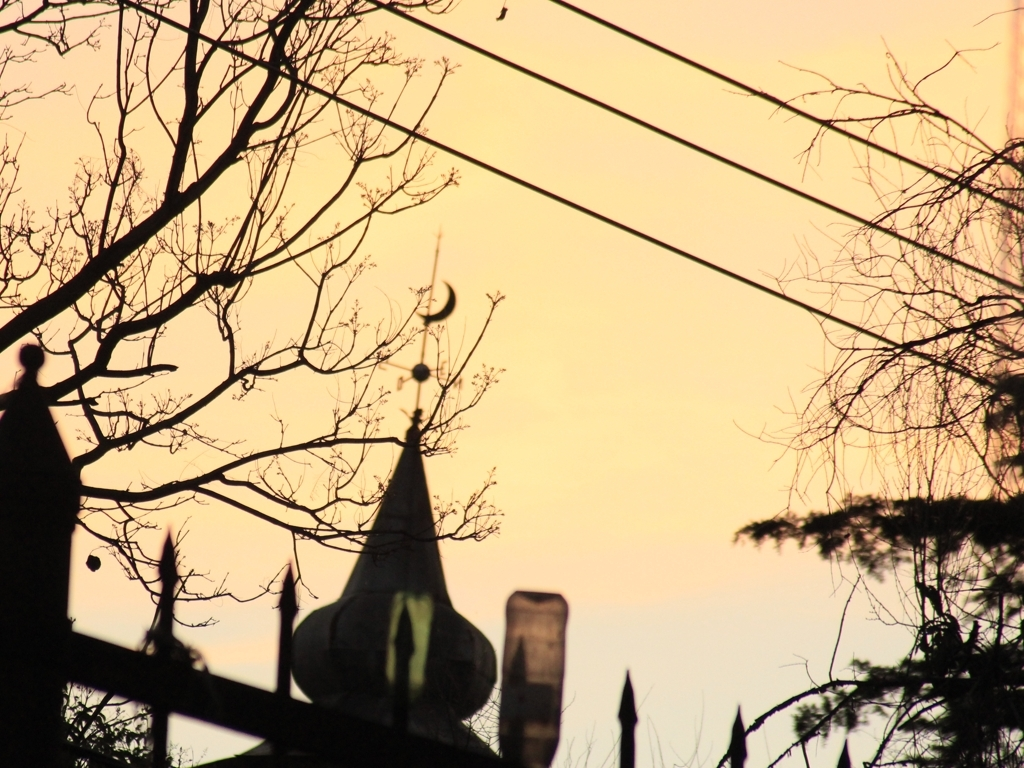Can you identify any notable features or landmarks depicted in the image? While details are limited by the silhouettes, the structure in the background bears the hallmark of an Islamic dome and minaret, possibly a mosque, signifying its cultural and religious importance. The silhouette creates a striking outline against the amber sky. 